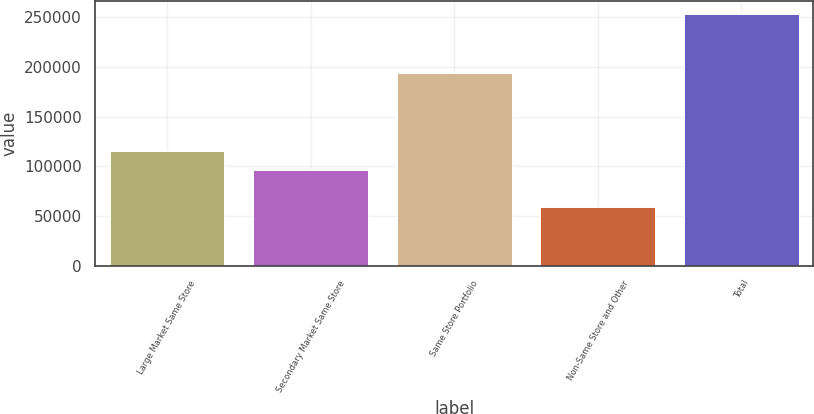<chart> <loc_0><loc_0><loc_500><loc_500><bar_chart><fcel>Large Market Same Store<fcel>Secondary Market Same Store<fcel>Same Store Portfolio<fcel>Non-Same Store and Other<fcel>Total<nl><fcel>115574<fcel>96141<fcel>194331<fcel>59302<fcel>253633<nl></chart> 